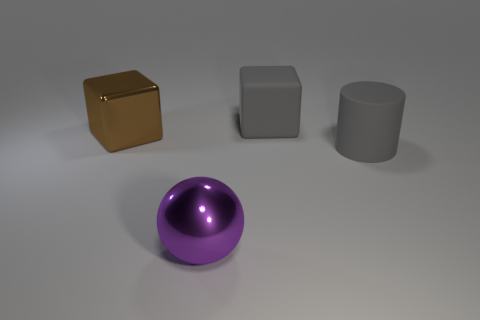There is a object that is both in front of the large brown metal block and to the right of the big purple metal ball; how big is it?
Your response must be concise. Large. What is the material of the object that is the same color as the big rubber cylinder?
Make the answer very short. Rubber. How many other cubes have the same color as the matte cube?
Offer a very short reply. 0. Is the number of cylinders behind the cylinder the same as the number of purple metal things?
Your response must be concise. No. What is the color of the cylinder?
Provide a succinct answer. Gray. What size is the ball that is the same material as the brown object?
Your answer should be compact. Large. There is a block that is the same material as the cylinder; what color is it?
Provide a short and direct response. Gray. Is there a matte cylinder that has the same size as the gray block?
Your response must be concise. Yes. There is a gray object that is the same shape as the big brown metal object; what is its material?
Provide a succinct answer. Rubber. There is a gray object that is the same size as the gray cylinder; what is its shape?
Give a very brief answer. Cube. 